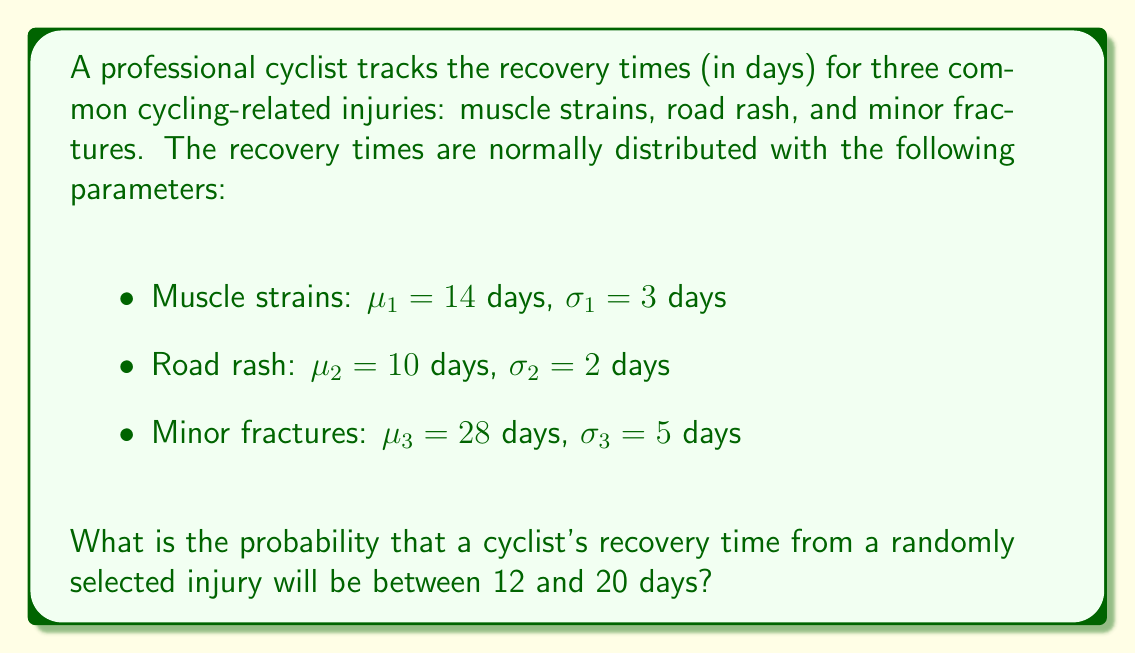Show me your answer to this math problem. To solve this problem, we need to follow these steps:

1) First, we need to calculate the probability for each injury type separately and then combine them.

2) For each injury type, we'll use the standard normal distribution (z-score) formula:
   $z = \frac{x - \mu}{\sigma}$

3) We'll then use a standard normal distribution table or calculator to find the area under the curve between our z-scores.

4) Finally, we'll average these probabilities, assuming each injury is equally likely.

Let's calculate for each injury type:

Muscle strains:
$z_1 = \frac{12 - 14}{3} = -0.67$
$z_2 = \frac{20 - 14}{3} = 2$
P(12 < X < 20) = P(-0.67 < Z < 2) = 0.7486 - 0.2514 = 0.4972

Road rash:
$z_1 = \frac{12 - 10}{2} = 1$
$z_2 = \frac{20 - 10}{2} = 5$
P(12 < X < 20) = P(1 < Z < 5) = 0.9999 - 0.8413 = 0.1586

Minor fractures:
$z_1 = \frac{12 - 28}{5} = -3.2$
$z_2 = \frac{20 - 28}{5} = -1.6$
P(12 < X < 20) = P(-3.2 < Z < -1.6) = 0.0548 - 0.0007 = 0.0541

5) Now, we average these probabilities:
   $\frac{0.4972 + 0.1586 + 0.0541}{3} = 0.2366$

Therefore, the probability that a cyclist's recovery time from a randomly selected injury will be between 12 and 20 days is approximately 0.2366 or 23.66%.
Answer: 0.2366 or 23.66% 